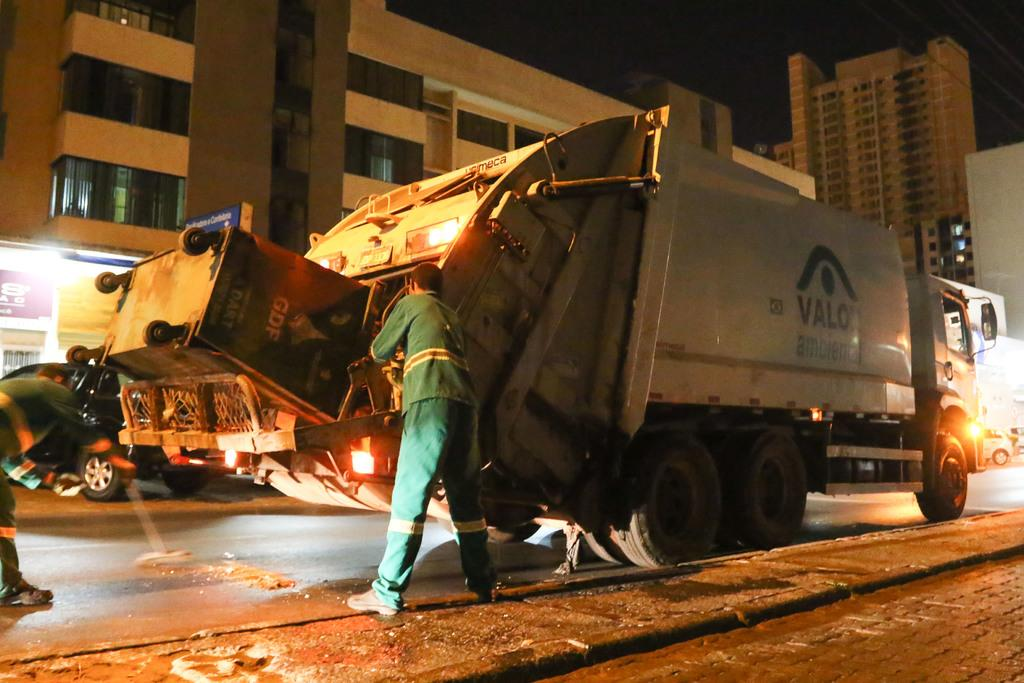How many people are on the road in the image? There are two people on the road in the image. What are the people near in the image? The people are near a truck. What is at the bottom of the image? There is a walkway at the bottom of the image. What can be seen in the background of the image? Buildings, vehicles, walls, and banners are visible in the background. What type of design can be seen on the donkey in the image? There is no donkey present in the image. What system is responsible for the organization of the banners in the image? The image does not provide information about the organization of the banners or any system responsible for it. 